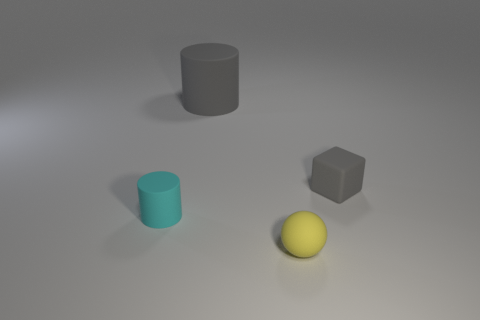What is the size of the cylinder that is the same color as the small rubber cube?
Your answer should be compact. Large. There is a tiny rubber ball; are there any yellow rubber objects to the right of it?
Keep it short and to the point. No. How many other things are the same shape as the large gray thing?
Your response must be concise. 1. There is a rubber cylinder that is the same size as the rubber block; what is its color?
Your answer should be compact. Cyan. Are there fewer yellow balls left of the tiny cyan thing than yellow matte balls left of the small yellow rubber sphere?
Your answer should be very brief. No. There is a cylinder in front of the matte cylinder behind the tiny matte cylinder; how many small cyan cylinders are to the right of it?
Your answer should be very brief. 0. What is the size of the gray object that is the same shape as the cyan matte thing?
Provide a short and direct response. Large. Is there anything else that is the same size as the yellow thing?
Your answer should be very brief. Yes. Is the number of small things to the right of the big gray cylinder less than the number of gray cylinders?
Your response must be concise. No. Do the tiny gray thing and the small cyan matte thing have the same shape?
Offer a terse response. No. 